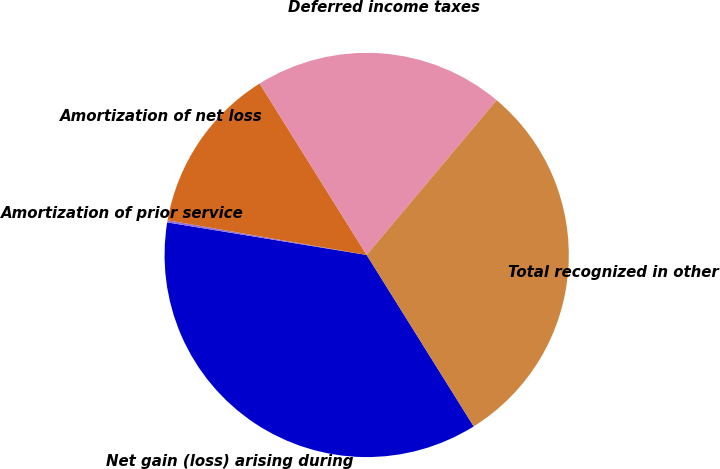Convert chart. <chart><loc_0><loc_0><loc_500><loc_500><pie_chart><fcel>Net gain (loss) arising during<fcel>Amortization of prior service<fcel>Amortization of net loss<fcel>Deferred income taxes<fcel>Total recognized in other<nl><fcel>36.46%<fcel>0.17%<fcel>13.37%<fcel>20.0%<fcel>30.0%<nl></chart> 